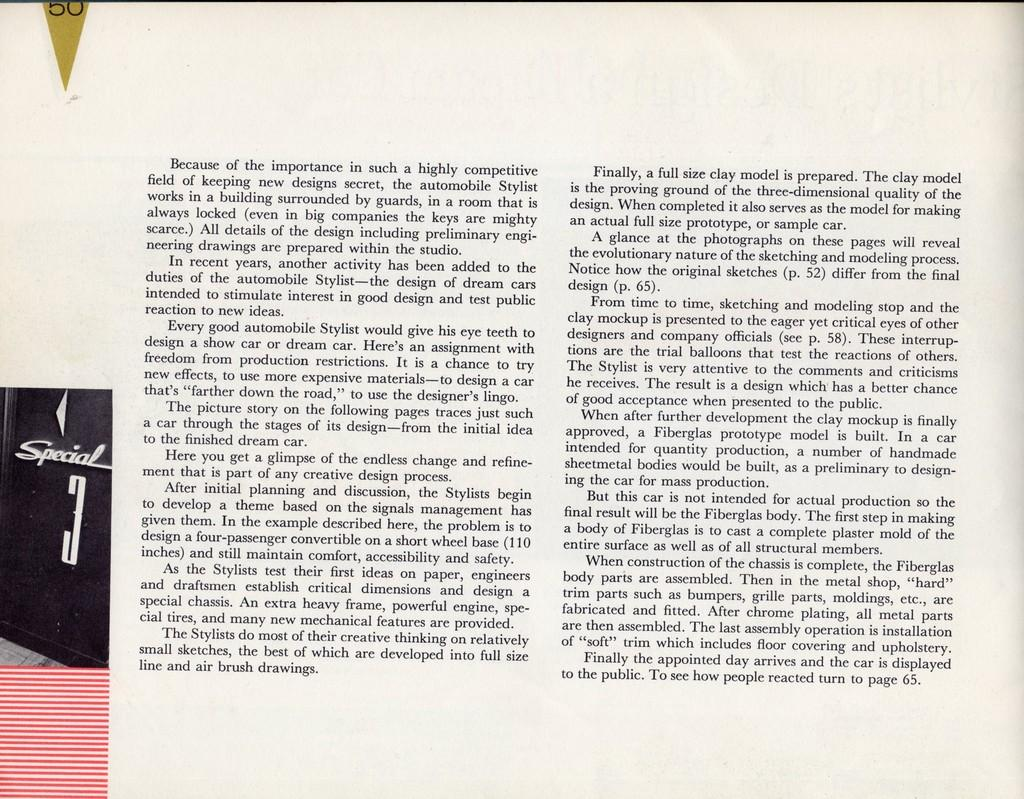<image>
Create a compact narrative representing the image presented. A book is open to a page describing what an automobile Stylist does 